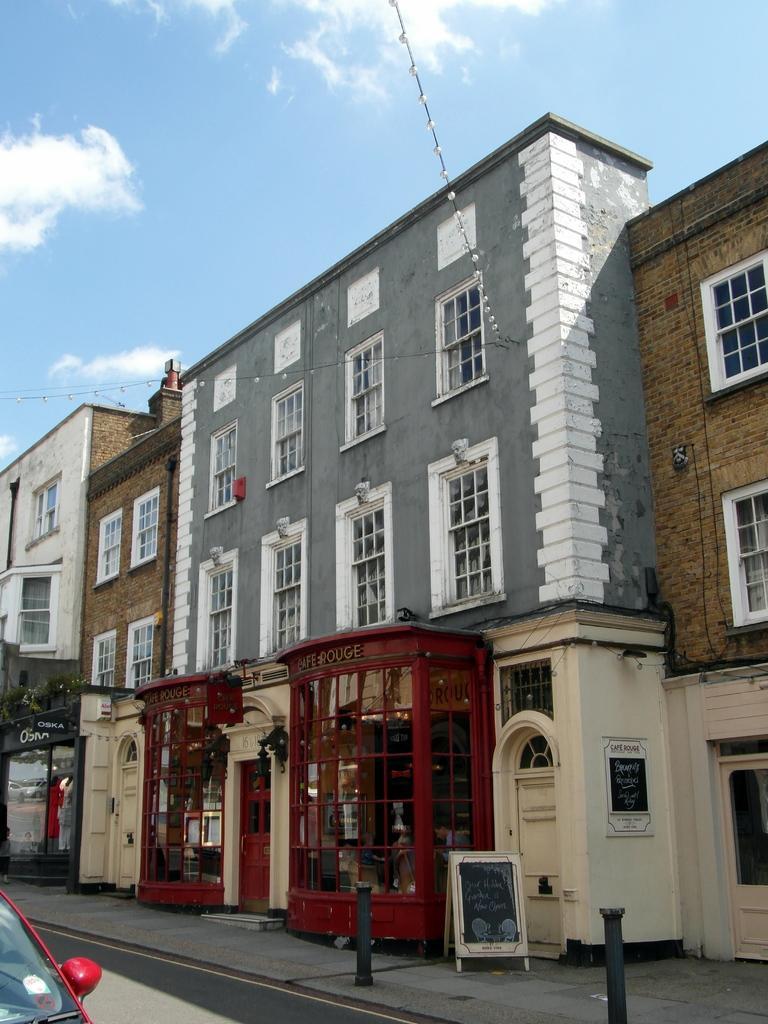Can you describe this image briefly? In this image there are some buildings in the middle of this image. There is a sky on the top of this image. There is a car on the road as we can see in the bottom left corner of this image. 